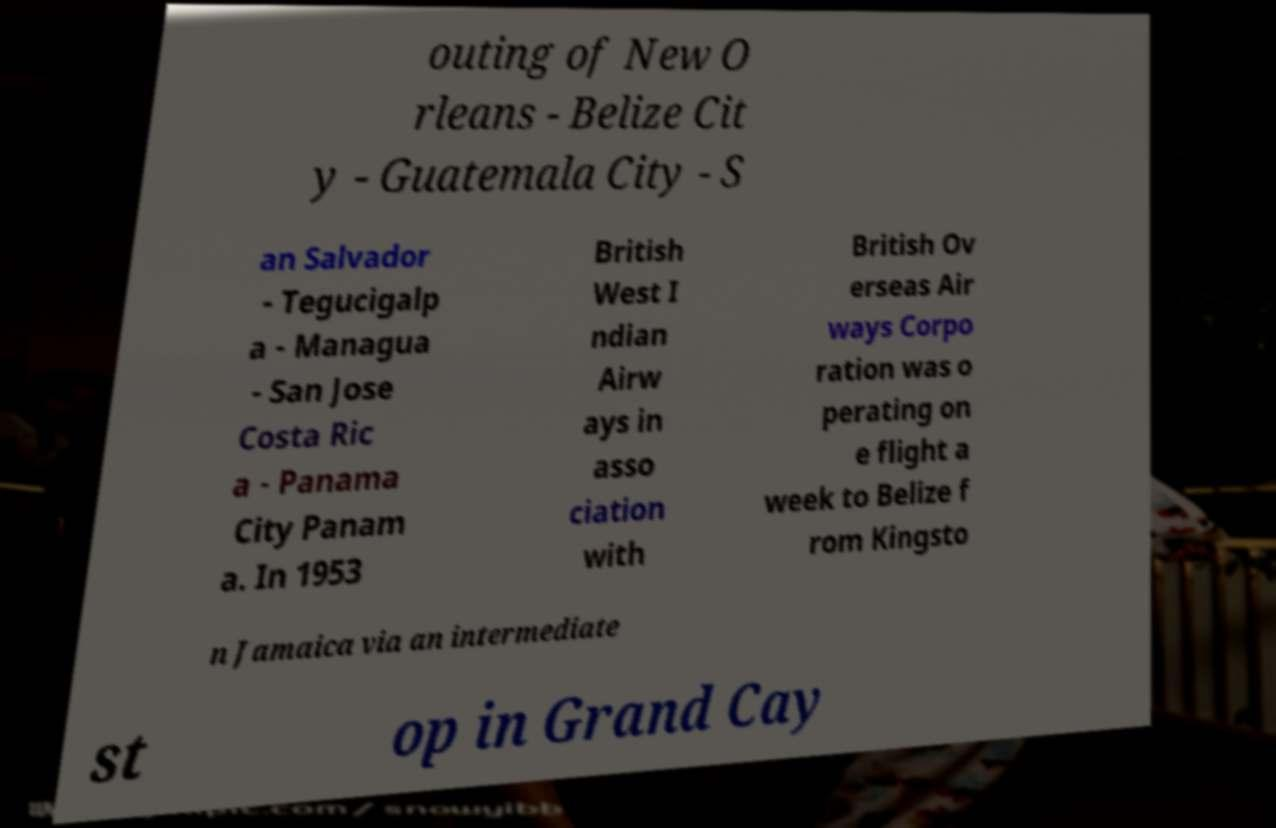Please read and relay the text visible in this image. What does it say? outing of New O rleans - Belize Cit y - Guatemala City - S an Salvador - Tegucigalp a - Managua - San Jose Costa Ric a - Panama City Panam a. In 1953 British West I ndian Airw ays in asso ciation with British Ov erseas Air ways Corpo ration was o perating on e flight a week to Belize f rom Kingsto n Jamaica via an intermediate st op in Grand Cay 